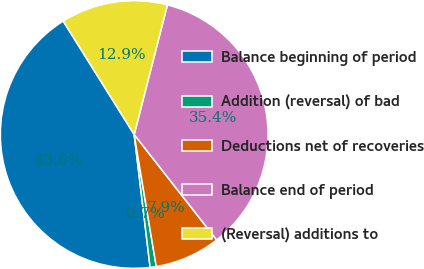Convert chart. <chart><loc_0><loc_0><loc_500><loc_500><pie_chart><fcel>Balance beginning of period<fcel>Addition (reversal) of bad<fcel>Deductions net of recoveries<fcel>Balance end of period<fcel>(Reversal) additions to<nl><fcel>43.0%<fcel>0.74%<fcel>7.93%<fcel>35.44%<fcel>12.89%<nl></chart> 